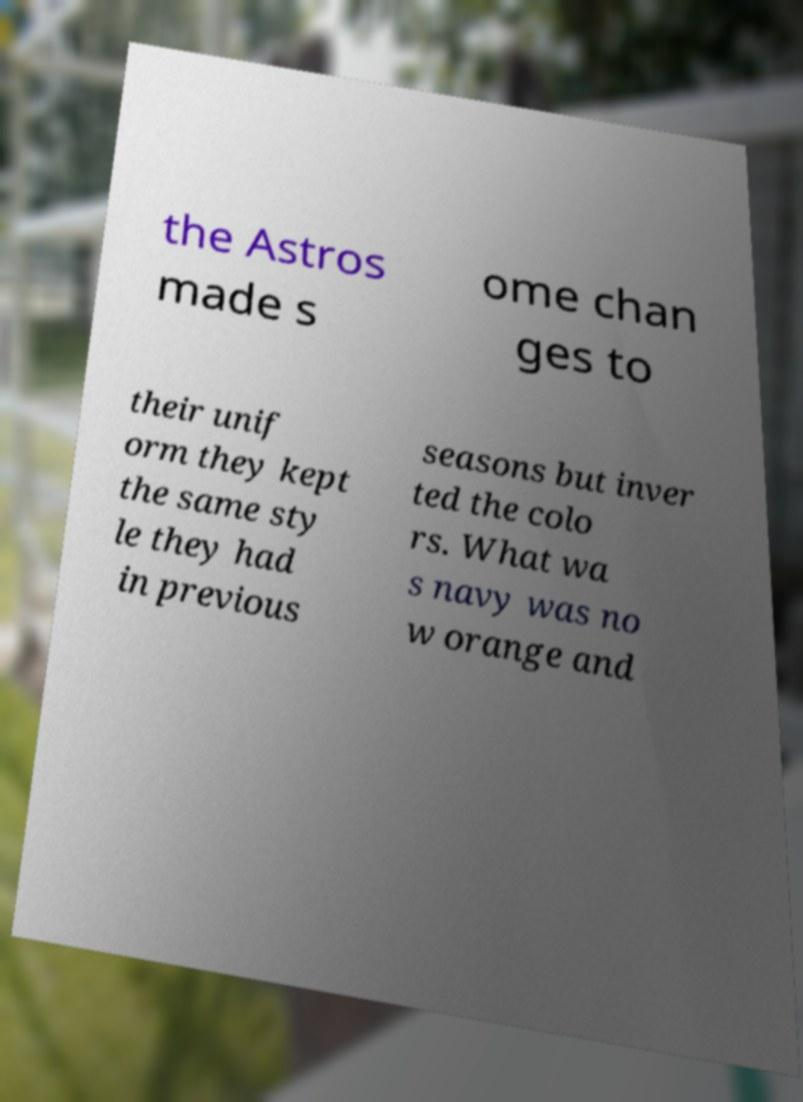There's text embedded in this image that I need extracted. Can you transcribe it verbatim? the Astros made s ome chan ges to their unif orm they kept the same sty le they had in previous seasons but inver ted the colo rs. What wa s navy was no w orange and 